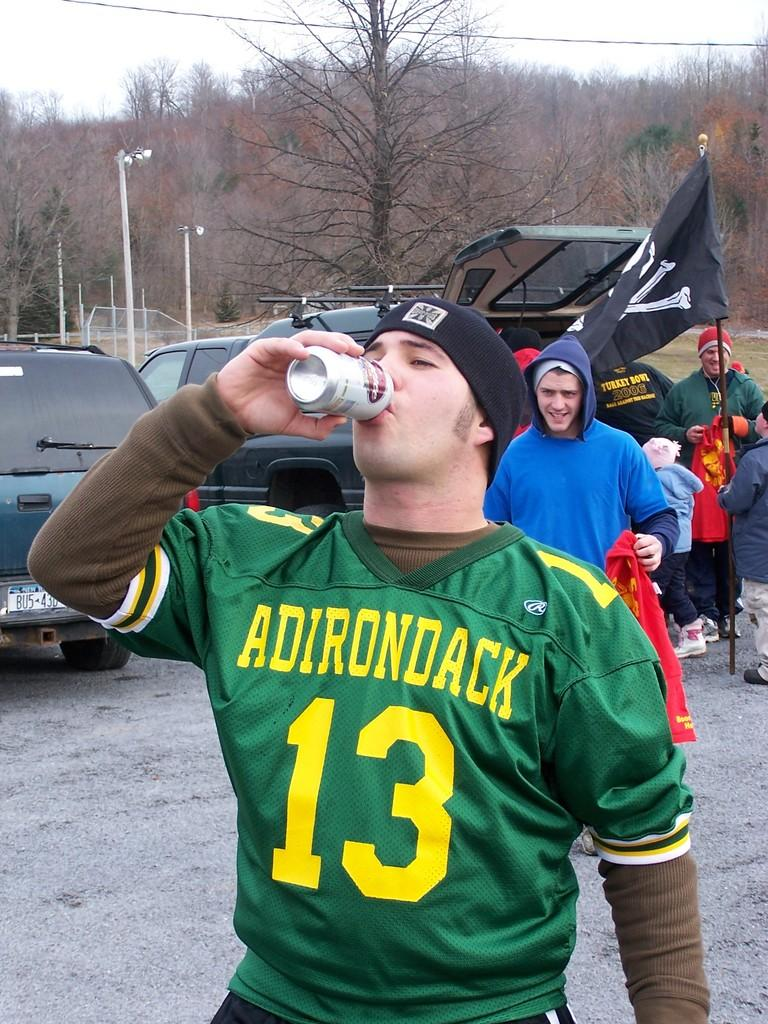<image>
Describe the image concisely. A young man wearing an Adirondack 13 shirt drinks a beer in a parking lot. 